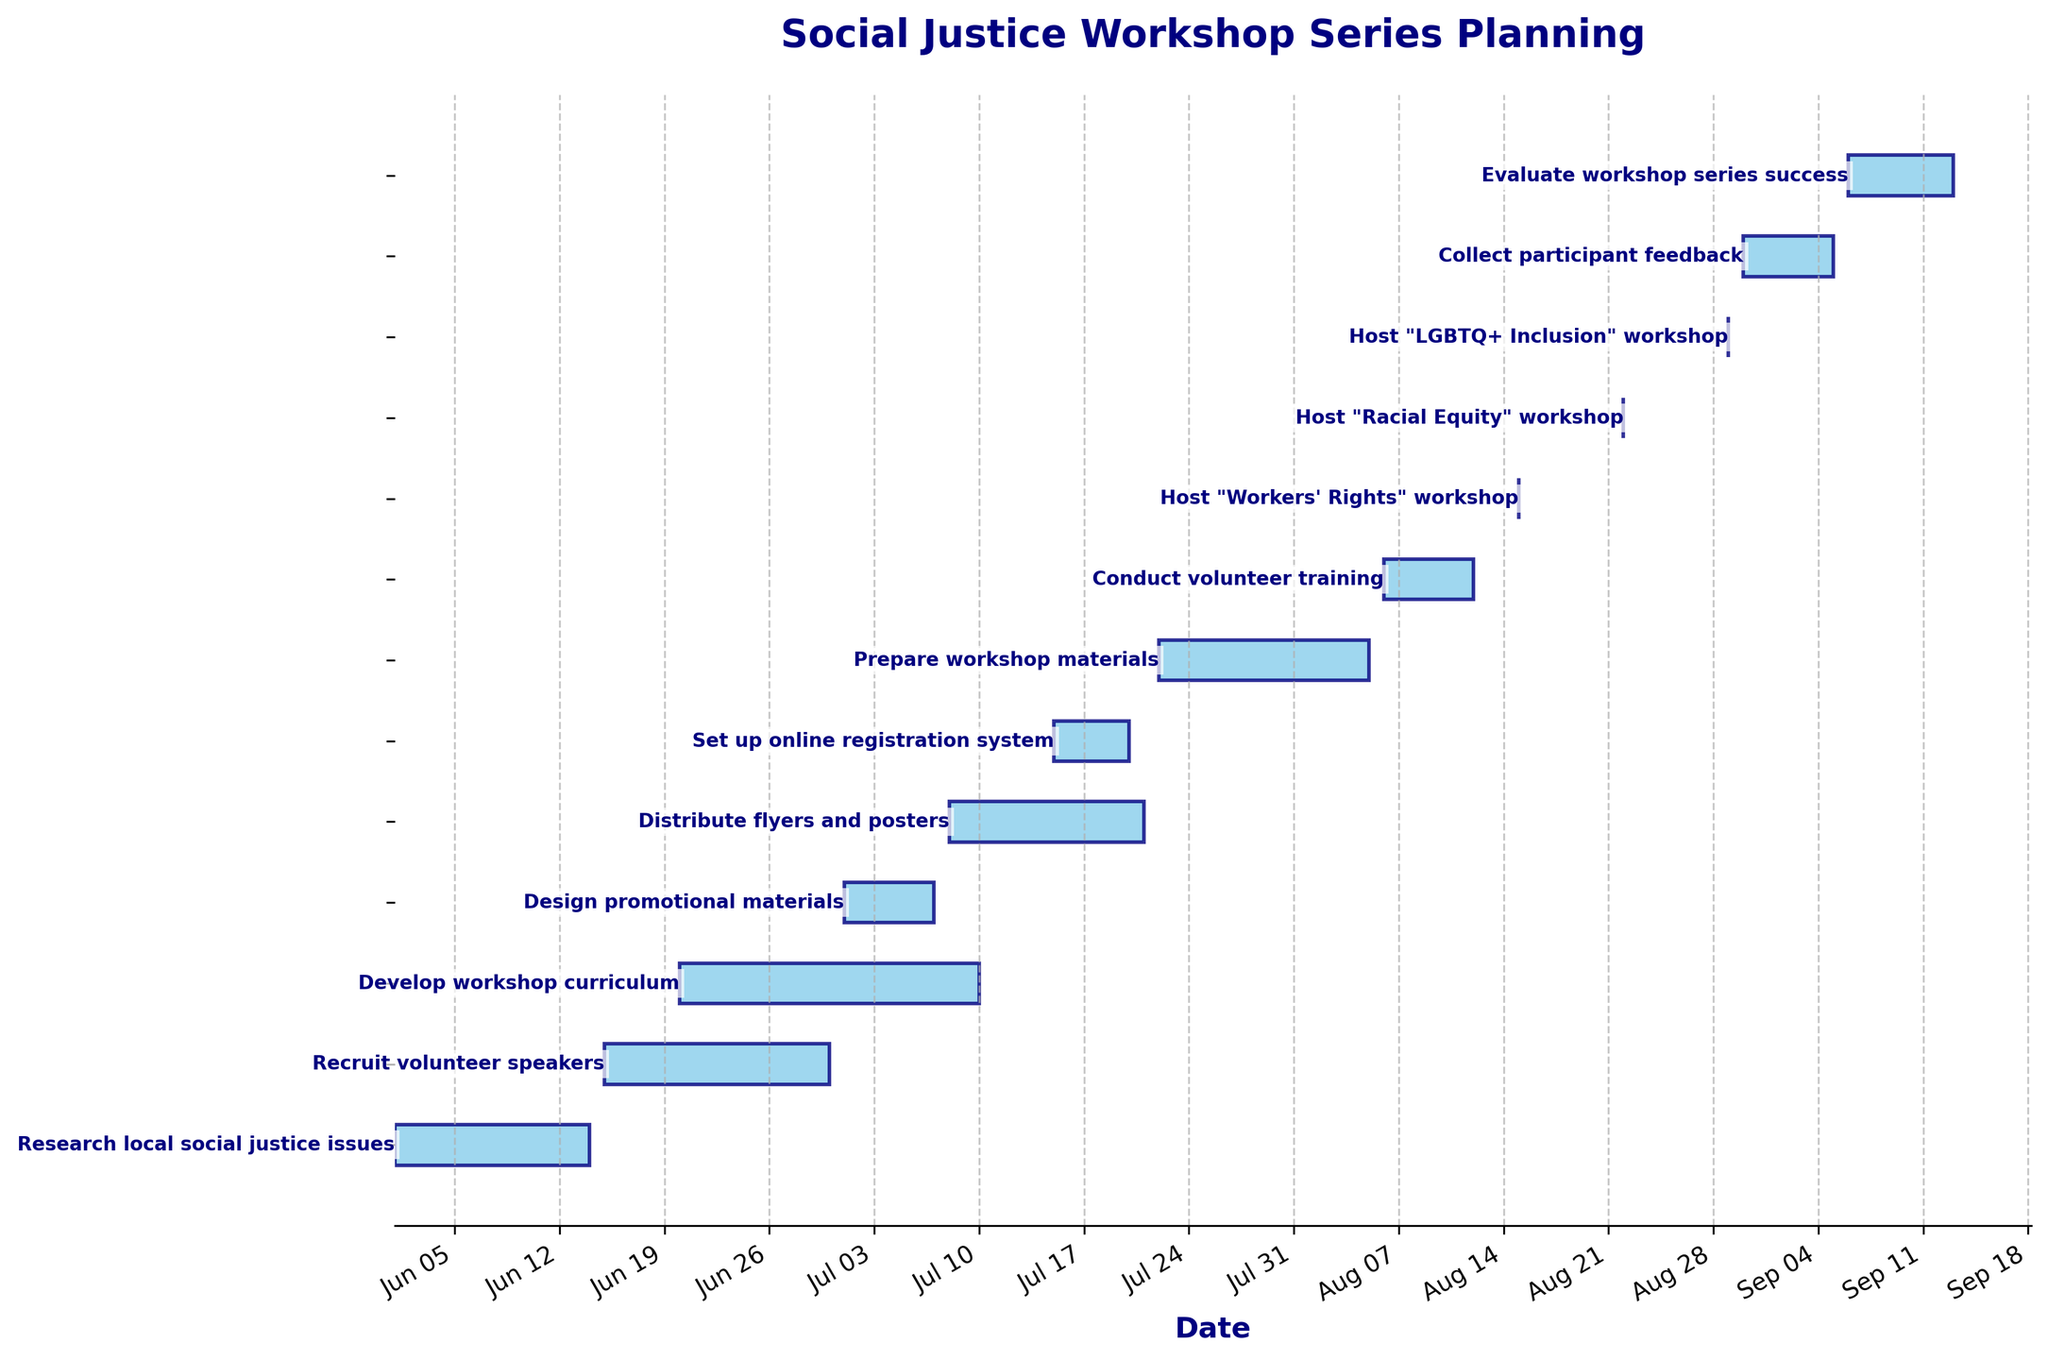What is the title of the Gantt chart? The title of the Gantt chart is usually displayed at the top of the figure.
Answer: Social Justice Workshop Series Planning What color are the bars in the Gantt chart? The color of the bars can be identified by looking at them visually.
Answer: Sky blue How many tasks are shown in the Gantt chart? Count the number of horizontal bars representing tasks.
Answer: 13 Which task has the shortest duration? The task with the shortest duration has the smallest bar length in days.
Answer: Host "Workers' Rights" workshop, Host "Racial Equity" workshop, Host "LGBTQ+ Inclusion" workshop When does the "Develop workshop curriculum" task end? Locate the "Develop workshop curriculum" task, then read its corresponding end date on the horizontal timeline.
Answer: July 10, 2023 What is the duration of the "Design promotional materials" task? Find the "Design promotional materials" task and count the number of days the bar spans.
Answer: 7 days Which task starts immediately after "Design promotional materials"? Find the end date of the "Design promotional materials" task, then identify the task that starts on the next day.
Answer: Distribute flyers and posters How long does it take to collect participant feedback and evaluate the workshop series success combined? Add the duration of "Collect participant feedback" and "Evaluate workshop series success" tasks.
Answer: 15 days Which tasks run concurrently with "Distribute flyers and posters"? Identify tasks that have overlapping date ranges with "Distribute flyers and posters".
Answer: Set up online registration system, Prepare workshop materials Which task has the longest duration? The task with the longest bar represents the longest duration. Measure the length and check the task.
Answer: Develop workshop curriculum 